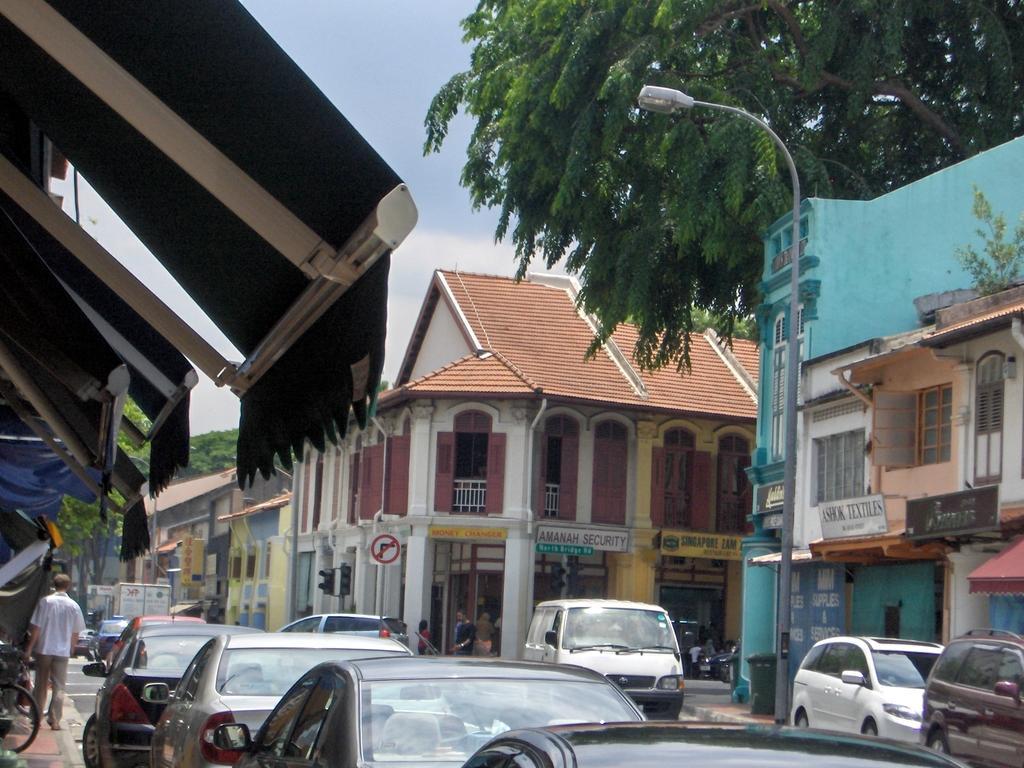Can you describe this image briefly? There are few buildings in the image, there is street light and a tree, a person is standing left most of the image and two persons are standing center of the image and talking to each other. 